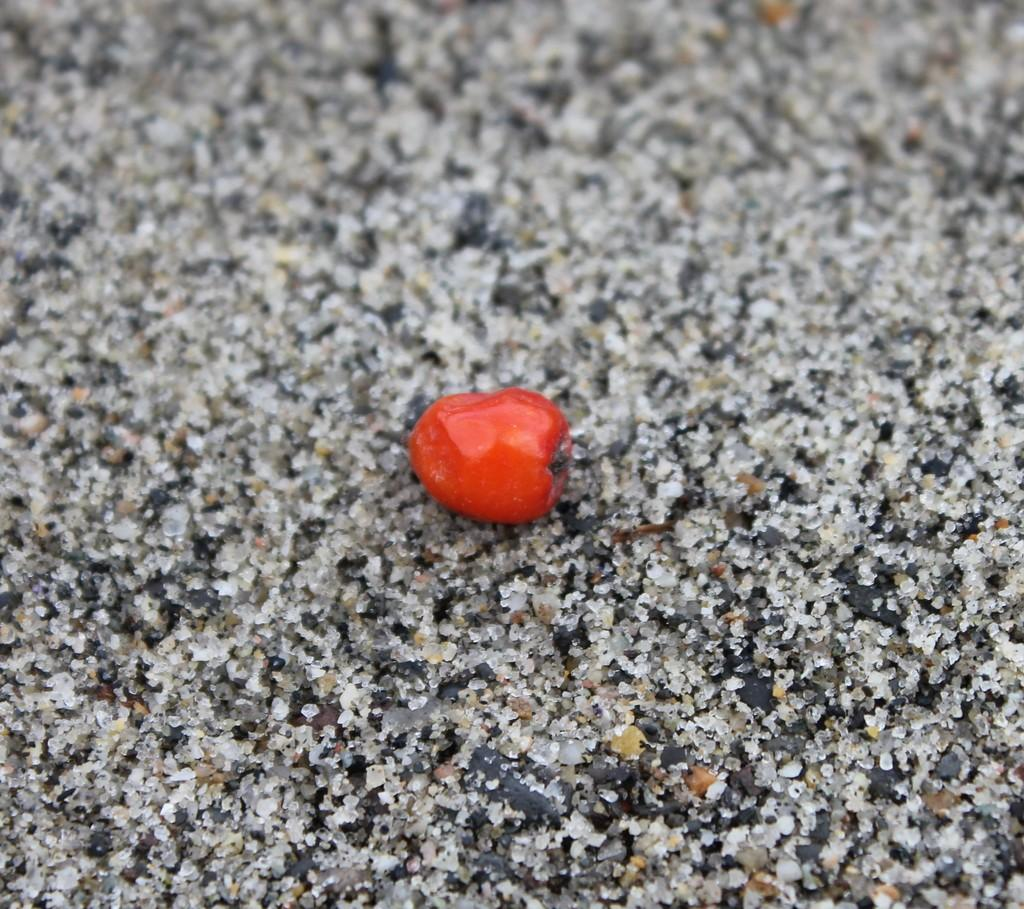What color is the fruit in the image? The fruit in the image is red. Where is the fruit located in the image? The fruit is on the ground. What position does the fruit hold in the family in the image? There is no family or position mentioned in the image; it only shows a red fruit on the ground. 